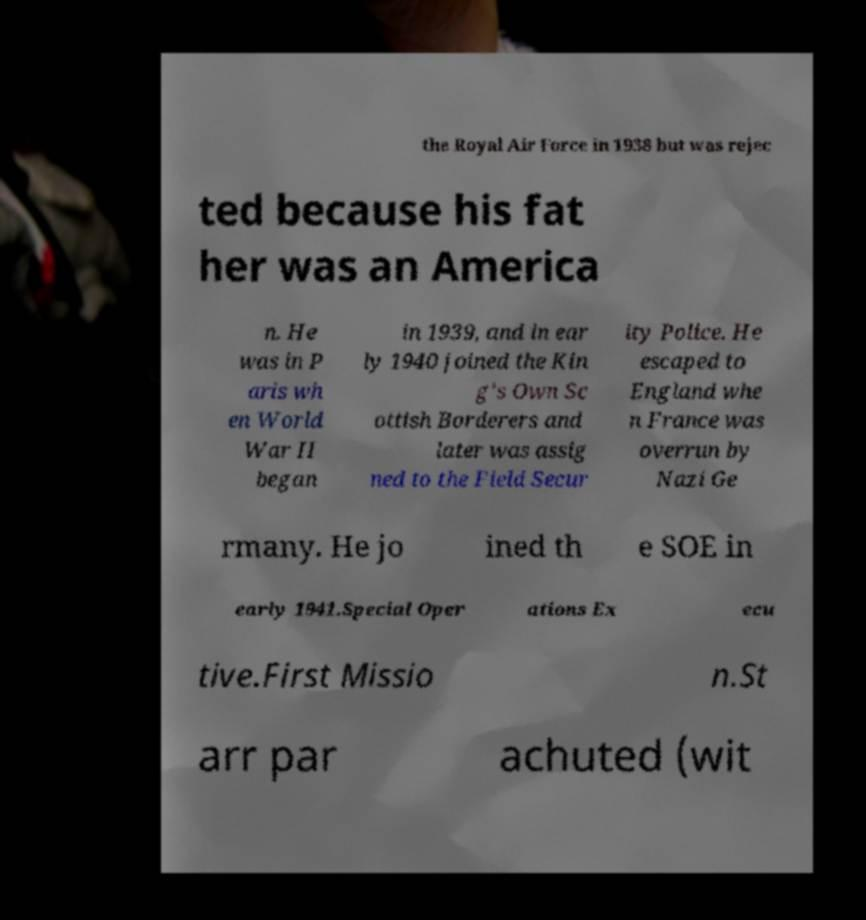Please identify and transcribe the text found in this image. the Royal Air Force in 1938 but was rejec ted because his fat her was an America n. He was in P aris wh en World War II began in 1939, and in ear ly 1940 joined the Kin g's Own Sc ottish Borderers and later was assig ned to the Field Secur ity Police. He escaped to England whe n France was overrun by Nazi Ge rmany. He jo ined th e SOE in early 1941.Special Oper ations Ex ecu tive.First Missio n.St arr par achuted (wit 